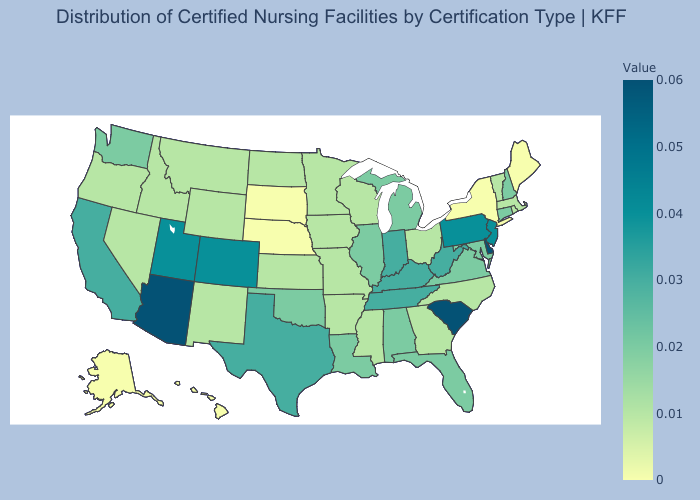Among the states that border New Hampshire , does Maine have the highest value?
Keep it brief. No. Among the states that border Utah , which have the highest value?
Short answer required. Arizona. Is the legend a continuous bar?
Keep it brief. Yes. Among the states that border South Dakota , which have the lowest value?
Write a very short answer. Nebraska. Does Kansas have the lowest value in the MidWest?
Keep it brief. No. Among the states that border Indiana , which have the highest value?
Answer briefly. Kentucky. Among the states that border Oklahoma , which have the lowest value?
Answer briefly. Arkansas, Kansas, Missouri, New Mexico. 